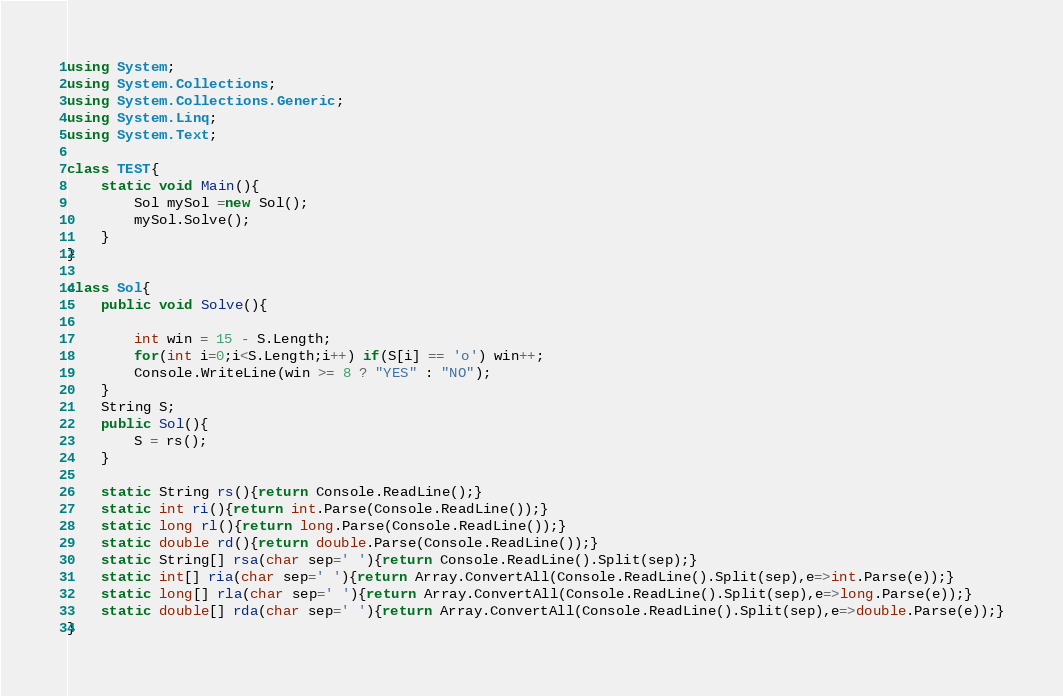Convert code to text. <code><loc_0><loc_0><loc_500><loc_500><_C#_>using System;
using System.Collections;
using System.Collections.Generic;
using System.Linq;
using System.Text;

class TEST{
	static void Main(){
		Sol mySol =new Sol();
		mySol.Solve();
	}
}

class Sol{
	public void Solve(){
		
		int win = 15 - S.Length;
		for(int i=0;i<S.Length;i++) if(S[i] == 'o') win++;
		Console.WriteLine(win >= 8 ? "YES" : "NO");
	}
	String S;
	public Sol(){
		S = rs();
	}

	static String rs(){return Console.ReadLine();}
	static int ri(){return int.Parse(Console.ReadLine());}
	static long rl(){return long.Parse(Console.ReadLine());}
	static double rd(){return double.Parse(Console.ReadLine());}
	static String[] rsa(char sep=' '){return Console.ReadLine().Split(sep);}
	static int[] ria(char sep=' '){return Array.ConvertAll(Console.ReadLine().Split(sep),e=>int.Parse(e));}
	static long[] rla(char sep=' '){return Array.ConvertAll(Console.ReadLine().Split(sep),e=>long.Parse(e));}
	static double[] rda(char sep=' '){return Array.ConvertAll(Console.ReadLine().Split(sep),e=>double.Parse(e));}
}
</code> 